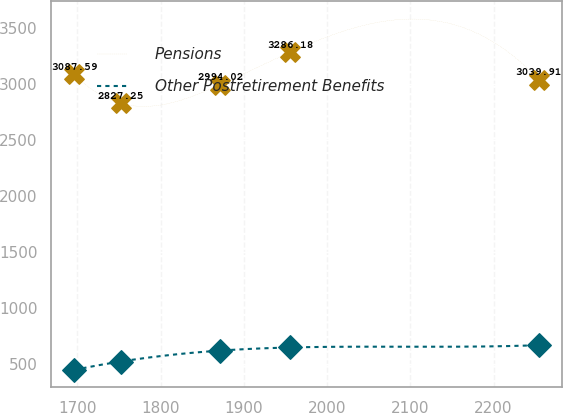Convert chart. <chart><loc_0><loc_0><loc_500><loc_500><line_chart><ecel><fcel>Pensions<fcel>Other Postretirement Benefits<nl><fcel>1696.18<fcel>3087.59<fcel>443.91<nl><fcel>1752<fcel>2827.25<fcel>518.98<nl><fcel>1871.61<fcel>2994.02<fcel>616.84<nl><fcel>1956.06<fcel>3286.18<fcel>644.66<nl><fcel>2254.38<fcel>3039.91<fcel>665.25<nl></chart> 